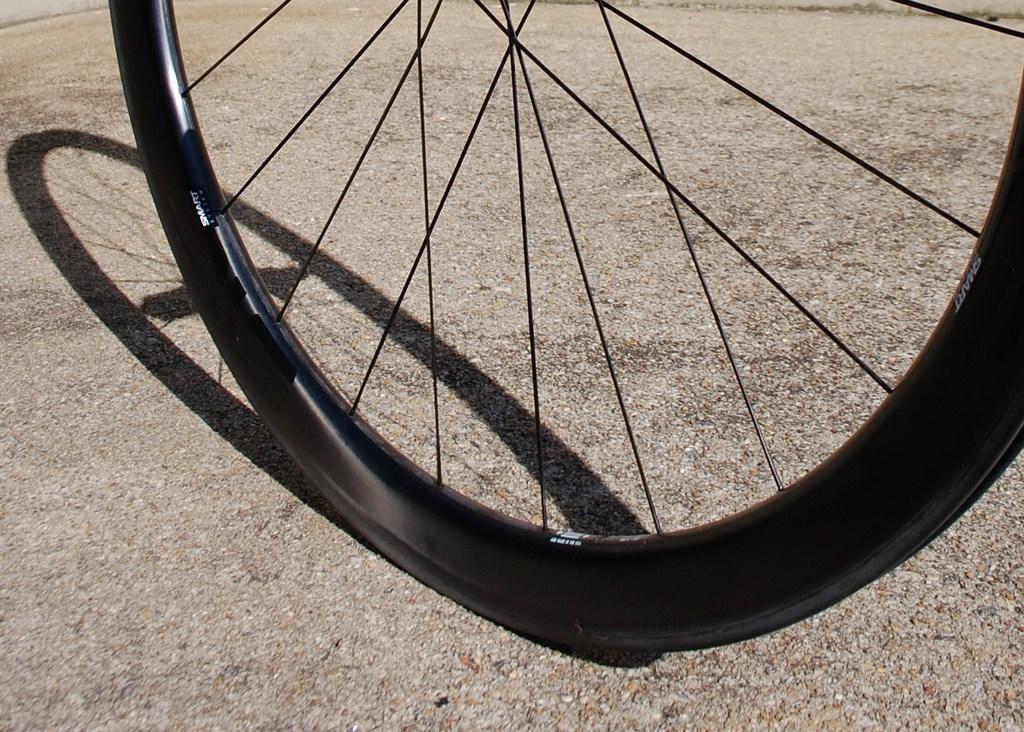How would you summarize this image in a sentence or two? In this image I can see the wheel in black color. It is on the surface. 